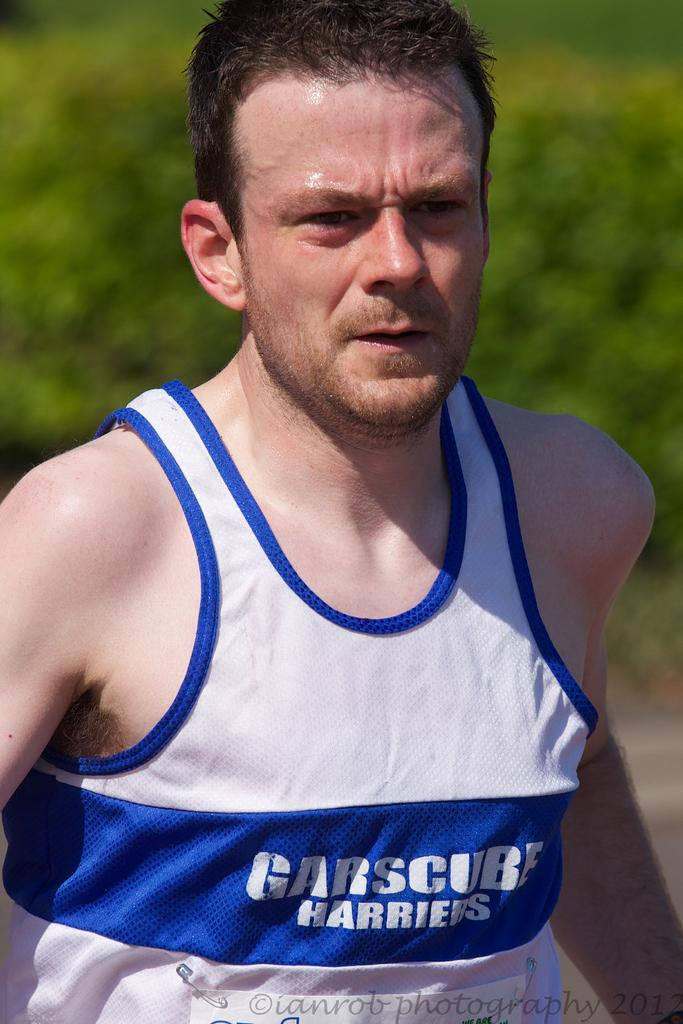Who is present in the image? There is a man in the image. What is the man wearing? The man is wearing a sleeveless bunny. Can you describe any accessories the man is wearing? There is a badge attached to the shirt with clips. What can be seen in the background of the image? There are trees in the background of the image. What type of fruit is the man holding in the image? There is no fruit present in the image; the man is wearing a sleeveless bunny and has a badge attached to his shirt. 